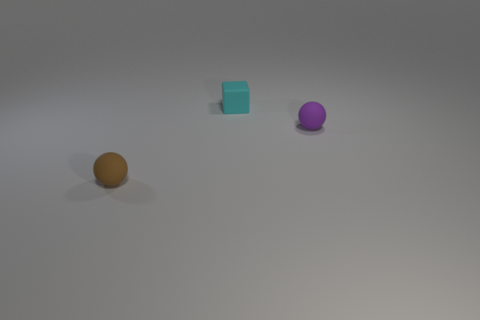Add 3 small spheres. How many objects exist? 6 Subtract all cubes. How many objects are left? 2 Subtract 0 red cylinders. How many objects are left? 3 Subtract all brown metal balls. Subtract all tiny balls. How many objects are left? 1 Add 2 tiny cyan blocks. How many tiny cyan blocks are left? 3 Add 3 cyan blocks. How many cyan blocks exist? 4 